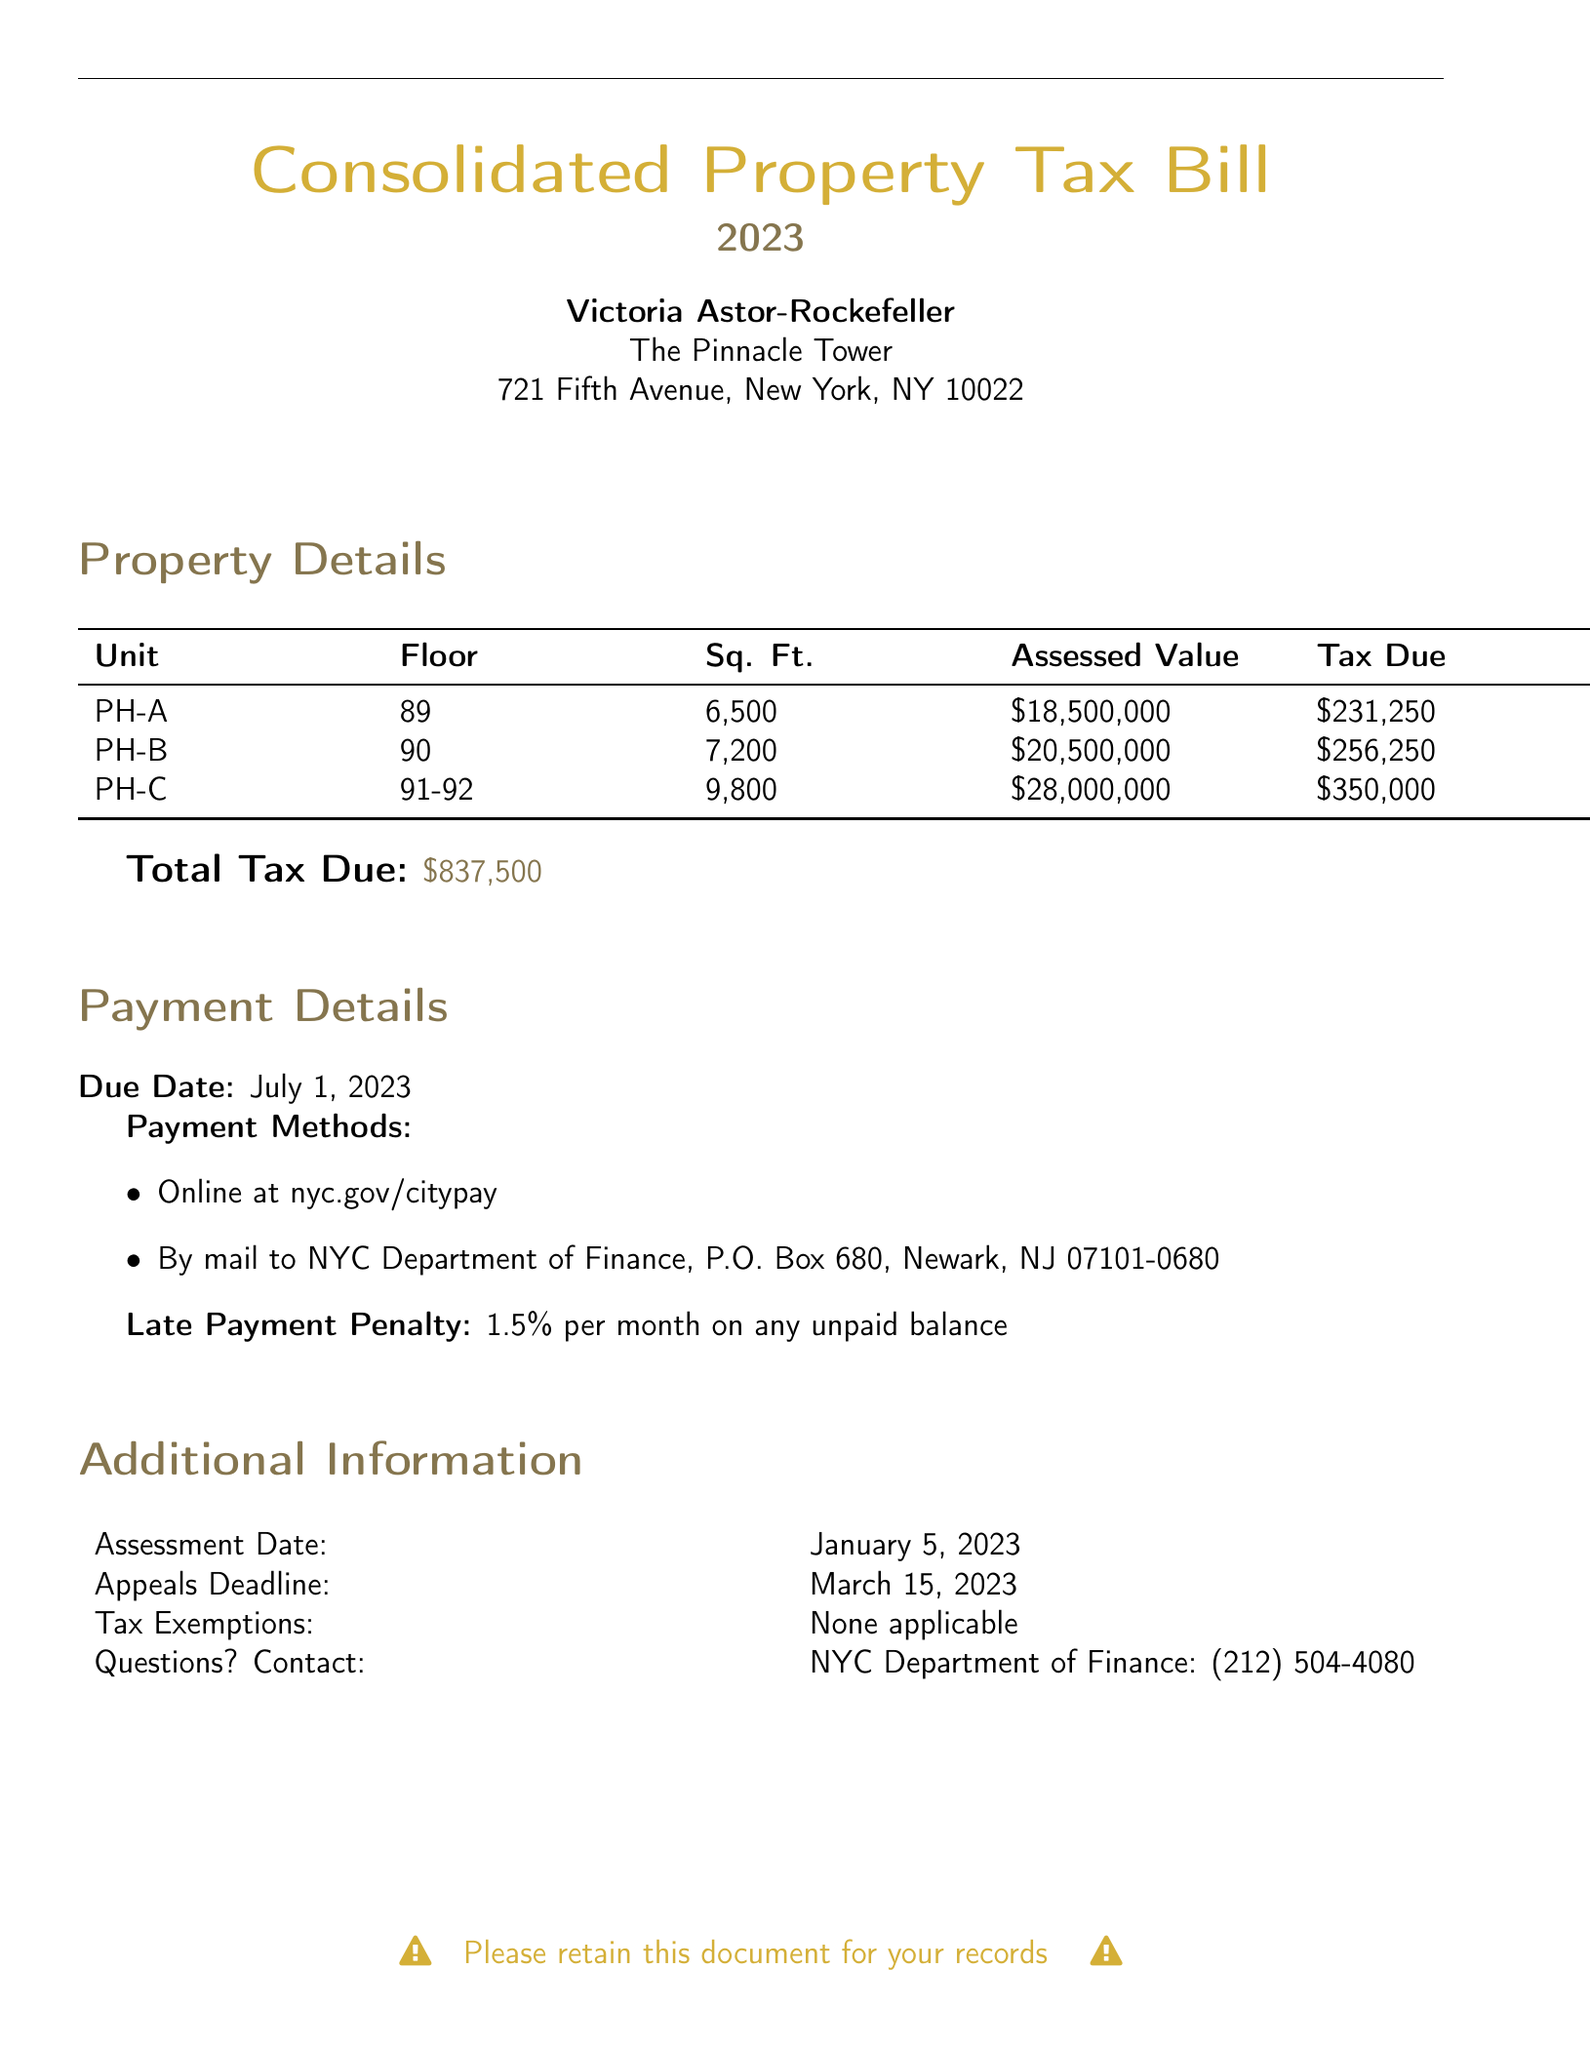What is the assessed value for PH-A? The assessed value for PH-A is listed in the property details section of the document.
Answer: $18,500,000 What is the total tax due? The total tax due is summarized at the end of the property details section.
Answer: $837,500 What is the due date for payment? The due date is specified in the payment details section.
Answer: July 1, 2023 How many square feet does PH-C have? The square feet measurement for PH-C can be found in the property details table.
Answer: 9,800 What is the late payment penalty rate? The late payment penalty rate is mentioned in the payment details section of the document.
Answer: 1.5% How many units are listed in the property details? The number of units can be counted from the property details table in the document.
Answer: 3 What is the assessment date? The assessment date is provided in the additional information section of the document.
Answer: January 5, 2023 What is the appeals deadline? The deadline for appeals is indicated in the additional information section.
Answer: March 15, 2023 